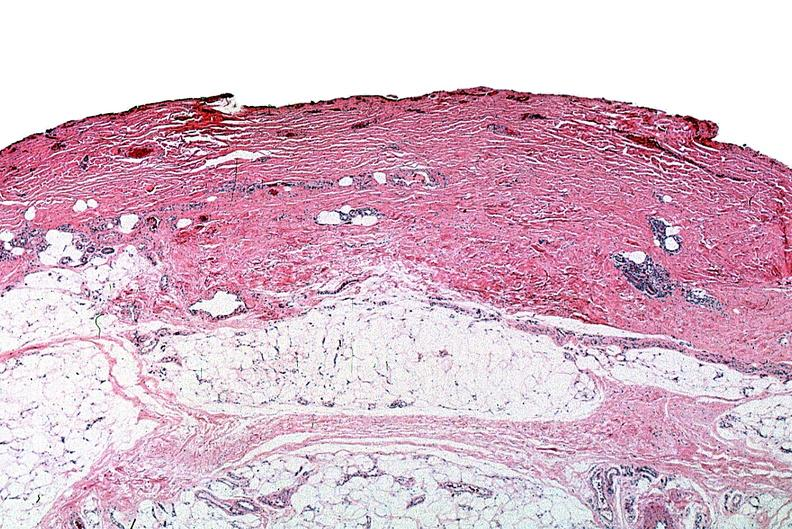does carcinomatous meningitis show thermal burned skin?
Answer the question using a single word or phrase. No 